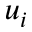<formula> <loc_0><loc_0><loc_500><loc_500>u _ { i }</formula> 